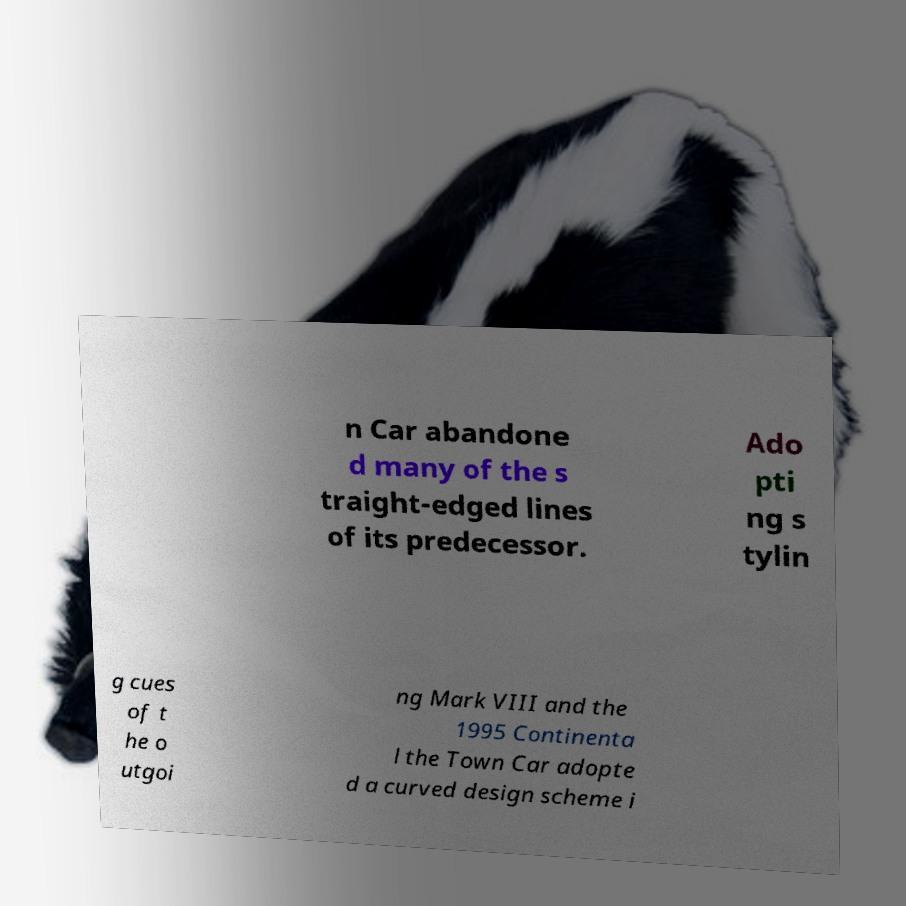There's text embedded in this image that I need extracted. Can you transcribe it verbatim? n Car abandone d many of the s traight-edged lines of its predecessor. Ado pti ng s tylin g cues of t he o utgoi ng Mark VIII and the 1995 Continenta l the Town Car adopte d a curved design scheme i 